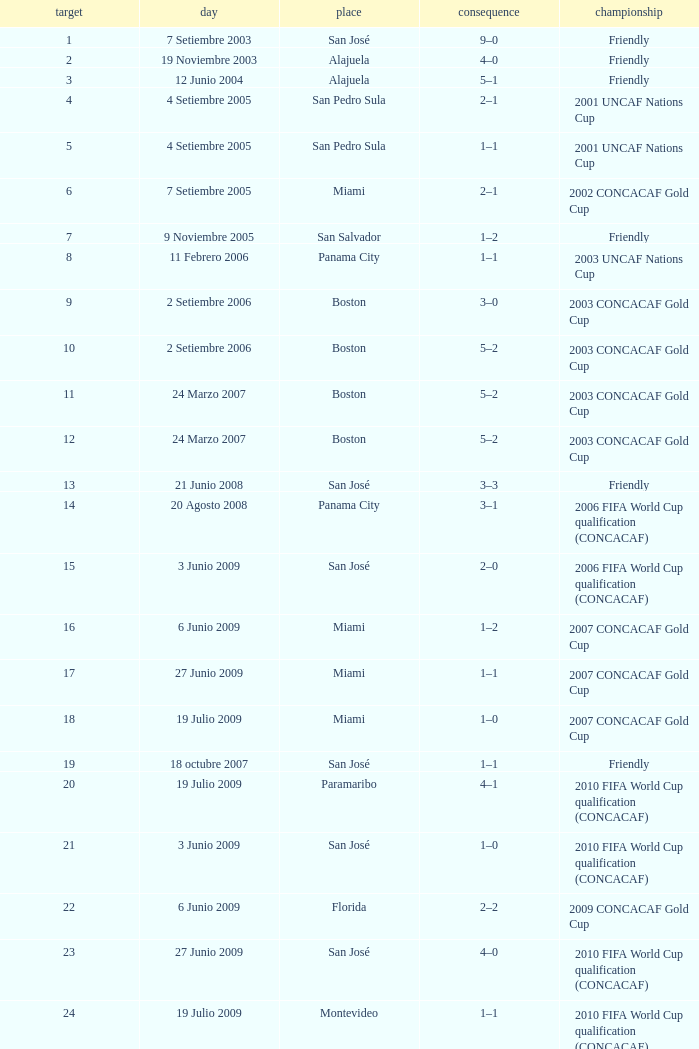How was the competition in which 6 goals were made? 2002 CONCACAF Gold Cup. Could you parse the entire table? {'header': ['target', 'day', 'place', 'consequence', 'championship'], 'rows': [['1', '7 Setiembre 2003', 'San José', '9–0', 'Friendly'], ['2', '19 Noviembre 2003', 'Alajuela', '4–0', 'Friendly'], ['3', '12 Junio 2004', 'Alajuela', '5–1', 'Friendly'], ['4', '4 Setiembre 2005', 'San Pedro Sula', '2–1', '2001 UNCAF Nations Cup'], ['5', '4 Setiembre 2005', 'San Pedro Sula', '1–1', '2001 UNCAF Nations Cup'], ['6', '7 Setiembre 2005', 'Miami', '2–1', '2002 CONCACAF Gold Cup'], ['7', '9 Noviembre 2005', 'San Salvador', '1–2', 'Friendly'], ['8', '11 Febrero 2006', 'Panama City', '1–1', '2003 UNCAF Nations Cup'], ['9', '2 Setiembre 2006', 'Boston', '3–0', '2003 CONCACAF Gold Cup'], ['10', '2 Setiembre 2006', 'Boston', '5–2', '2003 CONCACAF Gold Cup'], ['11', '24 Marzo 2007', 'Boston', '5–2', '2003 CONCACAF Gold Cup'], ['12', '24 Marzo 2007', 'Boston', '5–2', '2003 CONCACAF Gold Cup'], ['13', '21 Junio 2008', 'San José', '3–3', 'Friendly'], ['14', '20 Agosto 2008', 'Panama City', '3–1', '2006 FIFA World Cup qualification (CONCACAF)'], ['15', '3 Junio 2009', 'San José', '2–0', '2006 FIFA World Cup qualification (CONCACAF)'], ['16', '6 Junio 2009', 'Miami', '1–2', '2007 CONCACAF Gold Cup'], ['17', '27 Junio 2009', 'Miami', '1–1', '2007 CONCACAF Gold Cup'], ['18', '19 Julio 2009', 'Miami', '1–0', '2007 CONCACAF Gold Cup'], ['19', '18 octubre 2007', 'San José', '1–1', 'Friendly'], ['20', '19 Julio 2009', 'Paramaribo', '4–1', '2010 FIFA World Cup qualification (CONCACAF)'], ['21', '3 Junio 2009', 'San José', '1–0', '2010 FIFA World Cup qualification (CONCACAF)'], ['22', '6 Junio 2009', 'Florida', '2–2', '2009 CONCACAF Gold Cup'], ['23', '27 Junio 2009', 'San José', '4–0', '2010 FIFA World Cup qualification (CONCACAF)'], ['24', '19 Julio 2009', 'Montevideo', '1–1', '2010 FIFA World Cup qualification (CONCACAF)']]} 